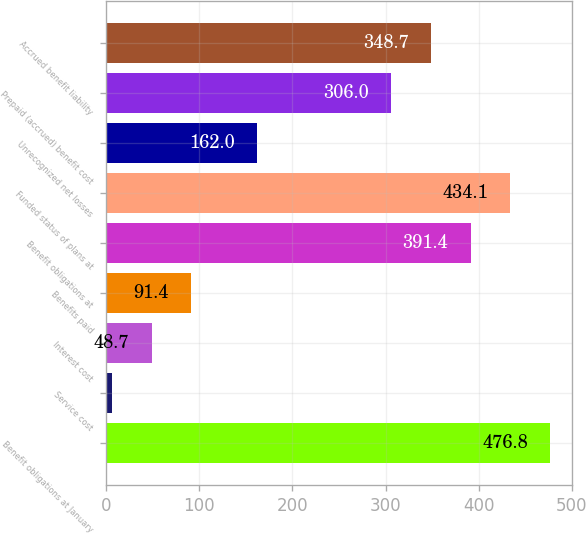Convert chart. <chart><loc_0><loc_0><loc_500><loc_500><bar_chart><fcel>Benefit obligations at January<fcel>Service cost<fcel>Interest cost<fcel>Benefits paid<fcel>Benefit obligations at<fcel>Funded status of plans at<fcel>Unrecognized net losses<fcel>Prepaid (accrued) benefit cost<fcel>Accrued benefit liability<nl><fcel>476.8<fcel>6<fcel>48.7<fcel>91.4<fcel>391.4<fcel>434.1<fcel>162<fcel>306<fcel>348.7<nl></chart> 